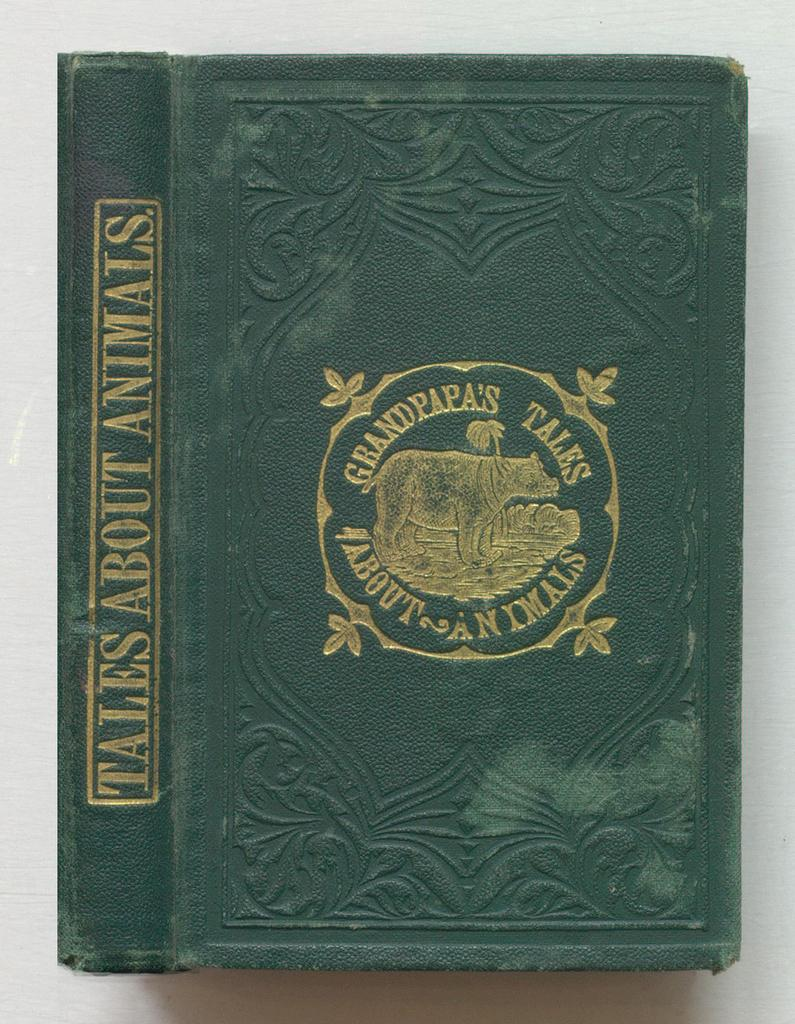<image>
Offer a succinct explanation of the picture presented. The book Grandpapas Tales about animals is an old green book 